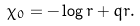<formula> <loc_0><loc_0><loc_500><loc_500>\chi _ { 0 } = - \log r + q r .</formula> 